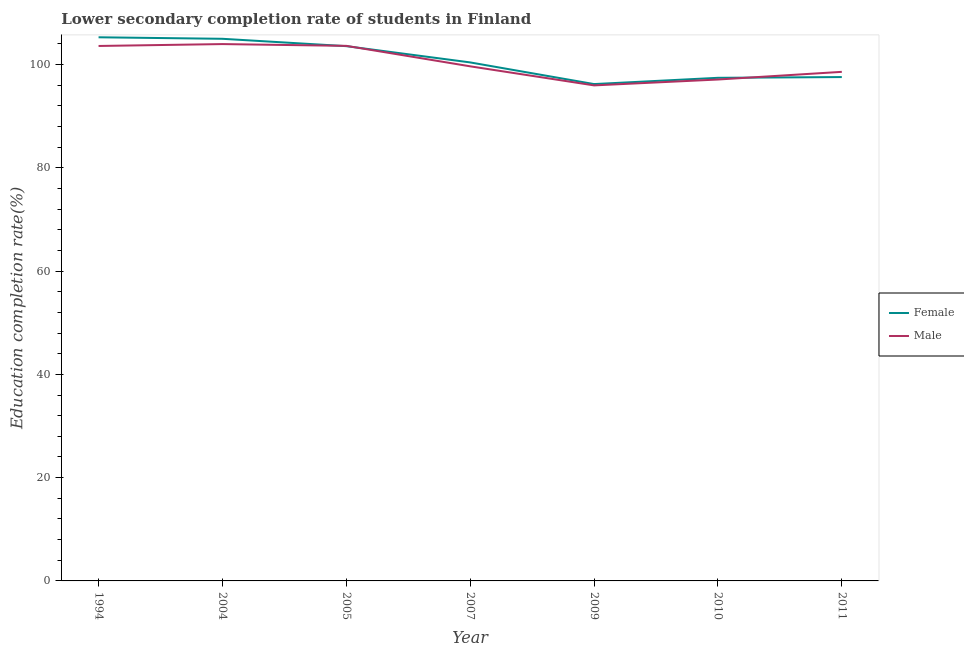Does the line corresponding to education completion rate of female students intersect with the line corresponding to education completion rate of male students?
Keep it short and to the point. Yes. What is the education completion rate of male students in 2004?
Your response must be concise. 103.95. Across all years, what is the maximum education completion rate of female students?
Keep it short and to the point. 105.27. Across all years, what is the minimum education completion rate of female students?
Offer a terse response. 96.21. In which year was the education completion rate of male students minimum?
Offer a terse response. 2009. What is the total education completion rate of male students in the graph?
Ensure brevity in your answer.  702.4. What is the difference between the education completion rate of male students in 2007 and that in 2011?
Ensure brevity in your answer.  1.07. What is the difference between the education completion rate of male students in 2011 and the education completion rate of female students in 2005?
Ensure brevity in your answer.  -4.97. What is the average education completion rate of male students per year?
Offer a terse response. 100.34. In the year 2009, what is the difference between the education completion rate of female students and education completion rate of male students?
Offer a terse response. 0.25. What is the ratio of the education completion rate of male students in 2004 to that in 2011?
Keep it short and to the point. 1.05. Is the education completion rate of male students in 2009 less than that in 2010?
Your answer should be very brief. Yes. Is the difference between the education completion rate of male students in 1994 and 2007 greater than the difference between the education completion rate of female students in 1994 and 2007?
Provide a short and direct response. No. What is the difference between the highest and the second highest education completion rate of female students?
Your answer should be very brief. 0.29. What is the difference between the highest and the lowest education completion rate of male students?
Ensure brevity in your answer.  8. In how many years, is the education completion rate of female students greater than the average education completion rate of female students taken over all years?
Your response must be concise. 3. Is the sum of the education completion rate of male students in 1994 and 2009 greater than the maximum education completion rate of female students across all years?
Keep it short and to the point. Yes. Does the education completion rate of male students monotonically increase over the years?
Give a very brief answer. No. How many lines are there?
Ensure brevity in your answer.  2. What is the difference between two consecutive major ticks on the Y-axis?
Make the answer very short. 20. Does the graph contain grids?
Ensure brevity in your answer.  No. How many legend labels are there?
Your response must be concise. 2. How are the legend labels stacked?
Give a very brief answer. Vertical. What is the title of the graph?
Make the answer very short. Lower secondary completion rate of students in Finland. Does "Secondary education" appear as one of the legend labels in the graph?
Your response must be concise. No. What is the label or title of the Y-axis?
Offer a very short reply. Education completion rate(%). What is the Education completion rate(%) in Female in 1994?
Provide a succinct answer. 105.27. What is the Education completion rate(%) in Male in 1994?
Provide a succinct answer. 103.58. What is the Education completion rate(%) of Female in 2004?
Give a very brief answer. 104.97. What is the Education completion rate(%) of Male in 2004?
Give a very brief answer. 103.95. What is the Education completion rate(%) of Female in 2005?
Your answer should be very brief. 103.55. What is the Education completion rate(%) of Male in 2005?
Provide a short and direct response. 103.61. What is the Education completion rate(%) in Female in 2007?
Your response must be concise. 100.4. What is the Education completion rate(%) in Male in 2007?
Offer a very short reply. 99.64. What is the Education completion rate(%) in Female in 2009?
Your answer should be very brief. 96.21. What is the Education completion rate(%) of Male in 2009?
Ensure brevity in your answer.  95.95. What is the Education completion rate(%) of Female in 2010?
Ensure brevity in your answer.  97.42. What is the Education completion rate(%) of Male in 2010?
Keep it short and to the point. 97.09. What is the Education completion rate(%) in Female in 2011?
Offer a very short reply. 97.56. What is the Education completion rate(%) in Male in 2011?
Offer a terse response. 98.57. Across all years, what is the maximum Education completion rate(%) of Female?
Make the answer very short. 105.27. Across all years, what is the maximum Education completion rate(%) in Male?
Offer a terse response. 103.95. Across all years, what is the minimum Education completion rate(%) of Female?
Your response must be concise. 96.21. Across all years, what is the minimum Education completion rate(%) in Male?
Your response must be concise. 95.95. What is the total Education completion rate(%) of Female in the graph?
Offer a very short reply. 705.38. What is the total Education completion rate(%) of Male in the graph?
Provide a succinct answer. 702.4. What is the difference between the Education completion rate(%) of Female in 1994 and that in 2004?
Your answer should be compact. 0.29. What is the difference between the Education completion rate(%) of Male in 1994 and that in 2004?
Your answer should be very brief. -0.37. What is the difference between the Education completion rate(%) of Female in 1994 and that in 2005?
Your answer should be very brief. 1.72. What is the difference between the Education completion rate(%) of Male in 1994 and that in 2005?
Your answer should be very brief. -0.02. What is the difference between the Education completion rate(%) in Female in 1994 and that in 2007?
Make the answer very short. 4.87. What is the difference between the Education completion rate(%) of Male in 1994 and that in 2007?
Give a very brief answer. 3.94. What is the difference between the Education completion rate(%) in Female in 1994 and that in 2009?
Keep it short and to the point. 9.06. What is the difference between the Education completion rate(%) in Male in 1994 and that in 2009?
Your answer should be compact. 7.63. What is the difference between the Education completion rate(%) of Female in 1994 and that in 2010?
Offer a terse response. 7.85. What is the difference between the Education completion rate(%) of Male in 1994 and that in 2010?
Keep it short and to the point. 6.5. What is the difference between the Education completion rate(%) of Female in 1994 and that in 2011?
Make the answer very short. 7.7. What is the difference between the Education completion rate(%) of Male in 1994 and that in 2011?
Your response must be concise. 5.01. What is the difference between the Education completion rate(%) in Female in 2004 and that in 2005?
Ensure brevity in your answer.  1.42. What is the difference between the Education completion rate(%) in Male in 2004 and that in 2005?
Ensure brevity in your answer.  0.35. What is the difference between the Education completion rate(%) of Female in 2004 and that in 2007?
Keep it short and to the point. 4.57. What is the difference between the Education completion rate(%) of Male in 2004 and that in 2007?
Keep it short and to the point. 4.31. What is the difference between the Education completion rate(%) in Female in 2004 and that in 2009?
Provide a short and direct response. 8.77. What is the difference between the Education completion rate(%) of Male in 2004 and that in 2009?
Give a very brief answer. 8. What is the difference between the Education completion rate(%) in Female in 2004 and that in 2010?
Offer a terse response. 7.56. What is the difference between the Education completion rate(%) in Male in 2004 and that in 2010?
Your answer should be compact. 6.86. What is the difference between the Education completion rate(%) of Female in 2004 and that in 2011?
Keep it short and to the point. 7.41. What is the difference between the Education completion rate(%) in Male in 2004 and that in 2011?
Your answer should be very brief. 5.38. What is the difference between the Education completion rate(%) in Female in 2005 and that in 2007?
Your answer should be compact. 3.15. What is the difference between the Education completion rate(%) of Male in 2005 and that in 2007?
Ensure brevity in your answer.  3.96. What is the difference between the Education completion rate(%) in Female in 2005 and that in 2009?
Offer a terse response. 7.34. What is the difference between the Education completion rate(%) in Male in 2005 and that in 2009?
Offer a terse response. 7.65. What is the difference between the Education completion rate(%) of Female in 2005 and that in 2010?
Your response must be concise. 6.13. What is the difference between the Education completion rate(%) of Male in 2005 and that in 2010?
Your answer should be compact. 6.52. What is the difference between the Education completion rate(%) in Female in 2005 and that in 2011?
Provide a succinct answer. 5.98. What is the difference between the Education completion rate(%) of Male in 2005 and that in 2011?
Provide a short and direct response. 5.03. What is the difference between the Education completion rate(%) of Female in 2007 and that in 2009?
Give a very brief answer. 4.19. What is the difference between the Education completion rate(%) of Male in 2007 and that in 2009?
Make the answer very short. 3.69. What is the difference between the Education completion rate(%) of Female in 2007 and that in 2010?
Give a very brief answer. 2.98. What is the difference between the Education completion rate(%) in Male in 2007 and that in 2010?
Offer a very short reply. 2.56. What is the difference between the Education completion rate(%) of Female in 2007 and that in 2011?
Provide a succinct answer. 2.83. What is the difference between the Education completion rate(%) in Male in 2007 and that in 2011?
Ensure brevity in your answer.  1.07. What is the difference between the Education completion rate(%) in Female in 2009 and that in 2010?
Keep it short and to the point. -1.21. What is the difference between the Education completion rate(%) of Male in 2009 and that in 2010?
Provide a short and direct response. -1.14. What is the difference between the Education completion rate(%) in Female in 2009 and that in 2011?
Your answer should be compact. -1.36. What is the difference between the Education completion rate(%) in Male in 2009 and that in 2011?
Your response must be concise. -2.62. What is the difference between the Education completion rate(%) in Female in 2010 and that in 2011?
Give a very brief answer. -0.15. What is the difference between the Education completion rate(%) in Male in 2010 and that in 2011?
Offer a very short reply. -1.49. What is the difference between the Education completion rate(%) in Female in 1994 and the Education completion rate(%) in Male in 2004?
Provide a succinct answer. 1.32. What is the difference between the Education completion rate(%) of Female in 1994 and the Education completion rate(%) of Male in 2005?
Provide a succinct answer. 1.66. What is the difference between the Education completion rate(%) of Female in 1994 and the Education completion rate(%) of Male in 2007?
Offer a terse response. 5.62. What is the difference between the Education completion rate(%) of Female in 1994 and the Education completion rate(%) of Male in 2009?
Your response must be concise. 9.32. What is the difference between the Education completion rate(%) of Female in 1994 and the Education completion rate(%) of Male in 2010?
Offer a very short reply. 8.18. What is the difference between the Education completion rate(%) in Female in 1994 and the Education completion rate(%) in Male in 2011?
Your answer should be compact. 6.69. What is the difference between the Education completion rate(%) in Female in 2004 and the Education completion rate(%) in Male in 2005?
Your response must be concise. 1.37. What is the difference between the Education completion rate(%) of Female in 2004 and the Education completion rate(%) of Male in 2007?
Your answer should be very brief. 5.33. What is the difference between the Education completion rate(%) in Female in 2004 and the Education completion rate(%) in Male in 2009?
Give a very brief answer. 9.02. What is the difference between the Education completion rate(%) of Female in 2004 and the Education completion rate(%) of Male in 2010?
Offer a terse response. 7.89. What is the difference between the Education completion rate(%) in Female in 2004 and the Education completion rate(%) in Male in 2011?
Your answer should be compact. 6.4. What is the difference between the Education completion rate(%) of Female in 2005 and the Education completion rate(%) of Male in 2007?
Provide a succinct answer. 3.91. What is the difference between the Education completion rate(%) in Female in 2005 and the Education completion rate(%) in Male in 2009?
Provide a succinct answer. 7.6. What is the difference between the Education completion rate(%) of Female in 2005 and the Education completion rate(%) of Male in 2010?
Offer a terse response. 6.46. What is the difference between the Education completion rate(%) in Female in 2005 and the Education completion rate(%) in Male in 2011?
Provide a succinct answer. 4.97. What is the difference between the Education completion rate(%) in Female in 2007 and the Education completion rate(%) in Male in 2009?
Your answer should be very brief. 4.45. What is the difference between the Education completion rate(%) of Female in 2007 and the Education completion rate(%) of Male in 2010?
Provide a short and direct response. 3.31. What is the difference between the Education completion rate(%) in Female in 2007 and the Education completion rate(%) in Male in 2011?
Offer a very short reply. 1.83. What is the difference between the Education completion rate(%) of Female in 2009 and the Education completion rate(%) of Male in 2010?
Your answer should be very brief. -0.88. What is the difference between the Education completion rate(%) in Female in 2009 and the Education completion rate(%) in Male in 2011?
Offer a very short reply. -2.37. What is the difference between the Education completion rate(%) in Female in 2010 and the Education completion rate(%) in Male in 2011?
Keep it short and to the point. -1.16. What is the average Education completion rate(%) of Female per year?
Your response must be concise. 100.77. What is the average Education completion rate(%) in Male per year?
Provide a succinct answer. 100.34. In the year 1994, what is the difference between the Education completion rate(%) of Female and Education completion rate(%) of Male?
Offer a very short reply. 1.68. In the year 2004, what is the difference between the Education completion rate(%) in Female and Education completion rate(%) in Male?
Make the answer very short. 1.02. In the year 2005, what is the difference between the Education completion rate(%) in Female and Education completion rate(%) in Male?
Make the answer very short. -0.06. In the year 2007, what is the difference between the Education completion rate(%) of Female and Education completion rate(%) of Male?
Provide a short and direct response. 0.76. In the year 2009, what is the difference between the Education completion rate(%) of Female and Education completion rate(%) of Male?
Offer a terse response. 0.25. In the year 2010, what is the difference between the Education completion rate(%) in Female and Education completion rate(%) in Male?
Keep it short and to the point. 0.33. In the year 2011, what is the difference between the Education completion rate(%) of Female and Education completion rate(%) of Male?
Make the answer very short. -1.01. What is the ratio of the Education completion rate(%) in Female in 1994 to that in 2004?
Offer a terse response. 1. What is the ratio of the Education completion rate(%) in Male in 1994 to that in 2004?
Your answer should be compact. 1. What is the ratio of the Education completion rate(%) of Female in 1994 to that in 2005?
Your answer should be very brief. 1.02. What is the ratio of the Education completion rate(%) in Female in 1994 to that in 2007?
Make the answer very short. 1.05. What is the ratio of the Education completion rate(%) in Male in 1994 to that in 2007?
Keep it short and to the point. 1.04. What is the ratio of the Education completion rate(%) in Female in 1994 to that in 2009?
Offer a very short reply. 1.09. What is the ratio of the Education completion rate(%) of Male in 1994 to that in 2009?
Your response must be concise. 1.08. What is the ratio of the Education completion rate(%) in Female in 1994 to that in 2010?
Provide a succinct answer. 1.08. What is the ratio of the Education completion rate(%) of Male in 1994 to that in 2010?
Ensure brevity in your answer.  1.07. What is the ratio of the Education completion rate(%) in Female in 1994 to that in 2011?
Ensure brevity in your answer.  1.08. What is the ratio of the Education completion rate(%) in Male in 1994 to that in 2011?
Ensure brevity in your answer.  1.05. What is the ratio of the Education completion rate(%) in Female in 2004 to that in 2005?
Ensure brevity in your answer.  1.01. What is the ratio of the Education completion rate(%) in Female in 2004 to that in 2007?
Offer a terse response. 1.05. What is the ratio of the Education completion rate(%) of Male in 2004 to that in 2007?
Offer a terse response. 1.04. What is the ratio of the Education completion rate(%) in Female in 2004 to that in 2009?
Offer a very short reply. 1.09. What is the ratio of the Education completion rate(%) of Male in 2004 to that in 2009?
Give a very brief answer. 1.08. What is the ratio of the Education completion rate(%) in Female in 2004 to that in 2010?
Provide a succinct answer. 1.08. What is the ratio of the Education completion rate(%) of Male in 2004 to that in 2010?
Ensure brevity in your answer.  1.07. What is the ratio of the Education completion rate(%) in Female in 2004 to that in 2011?
Offer a terse response. 1.08. What is the ratio of the Education completion rate(%) of Male in 2004 to that in 2011?
Your answer should be compact. 1.05. What is the ratio of the Education completion rate(%) of Female in 2005 to that in 2007?
Provide a succinct answer. 1.03. What is the ratio of the Education completion rate(%) in Male in 2005 to that in 2007?
Your answer should be very brief. 1.04. What is the ratio of the Education completion rate(%) of Female in 2005 to that in 2009?
Your answer should be very brief. 1.08. What is the ratio of the Education completion rate(%) in Male in 2005 to that in 2009?
Ensure brevity in your answer.  1.08. What is the ratio of the Education completion rate(%) in Female in 2005 to that in 2010?
Offer a terse response. 1.06. What is the ratio of the Education completion rate(%) in Male in 2005 to that in 2010?
Your answer should be compact. 1.07. What is the ratio of the Education completion rate(%) of Female in 2005 to that in 2011?
Ensure brevity in your answer.  1.06. What is the ratio of the Education completion rate(%) of Male in 2005 to that in 2011?
Your answer should be compact. 1.05. What is the ratio of the Education completion rate(%) of Female in 2007 to that in 2009?
Your response must be concise. 1.04. What is the ratio of the Education completion rate(%) of Female in 2007 to that in 2010?
Offer a very short reply. 1.03. What is the ratio of the Education completion rate(%) of Male in 2007 to that in 2010?
Your response must be concise. 1.03. What is the ratio of the Education completion rate(%) of Female in 2007 to that in 2011?
Keep it short and to the point. 1.03. What is the ratio of the Education completion rate(%) of Male in 2007 to that in 2011?
Make the answer very short. 1.01. What is the ratio of the Education completion rate(%) of Female in 2009 to that in 2010?
Keep it short and to the point. 0.99. What is the ratio of the Education completion rate(%) in Male in 2009 to that in 2010?
Keep it short and to the point. 0.99. What is the ratio of the Education completion rate(%) in Female in 2009 to that in 2011?
Your answer should be compact. 0.99. What is the ratio of the Education completion rate(%) in Male in 2009 to that in 2011?
Ensure brevity in your answer.  0.97. What is the ratio of the Education completion rate(%) of Male in 2010 to that in 2011?
Your response must be concise. 0.98. What is the difference between the highest and the second highest Education completion rate(%) in Female?
Provide a short and direct response. 0.29. What is the difference between the highest and the second highest Education completion rate(%) of Male?
Keep it short and to the point. 0.35. What is the difference between the highest and the lowest Education completion rate(%) in Female?
Your response must be concise. 9.06. 